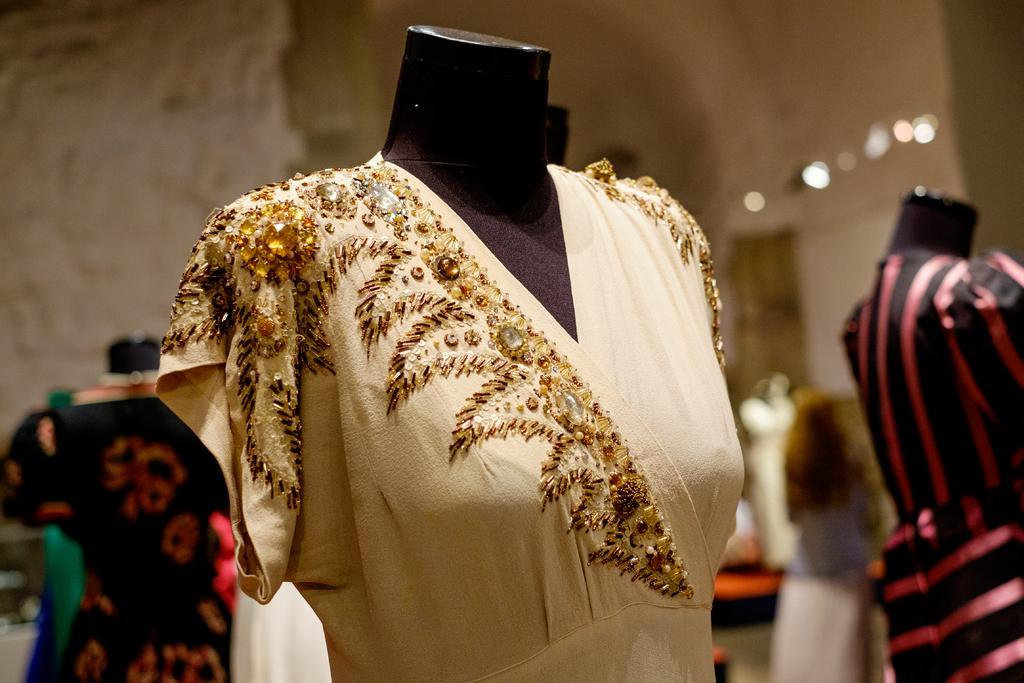Describe this image in one or two sentences. In this picture we can see mannequins, dressed and in the background we can see the lights, some objects and it is blurry. 